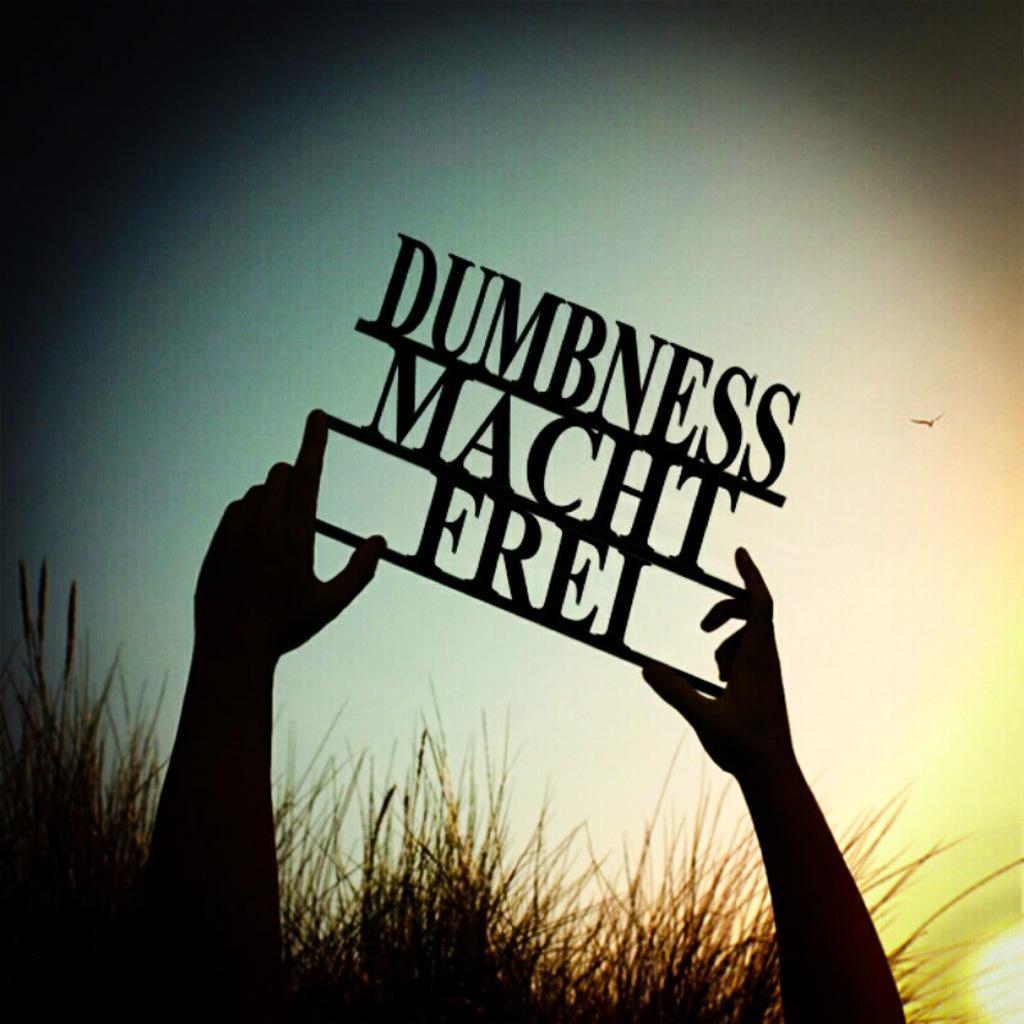How would you summarize this image in a sentence or two? In this image, we can see there is a person holding an object with both hands. This object is having letters. In the background, there is grass on the ground, there is a light, there is a bird in the air and there is sky. 